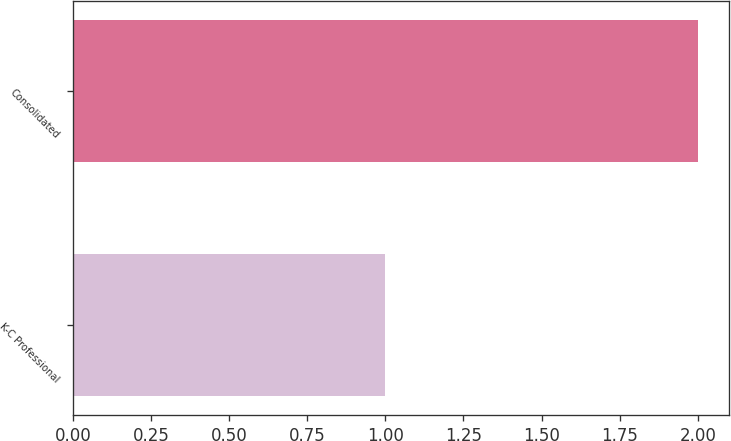Convert chart. <chart><loc_0><loc_0><loc_500><loc_500><bar_chart><fcel>K-C Professional<fcel>Consolidated<nl><fcel>1<fcel>2<nl></chart> 